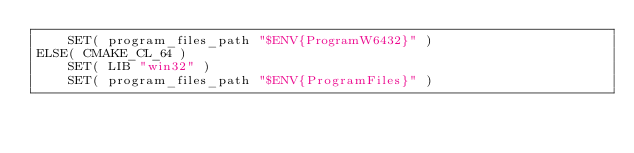Convert code to text. <code><loc_0><loc_0><loc_500><loc_500><_CMake_>    SET( program_files_path "$ENV{ProgramW6432}" )
ELSE( CMAKE_CL_64 )
    SET( LIB "win32" )
    SET( program_files_path "$ENV{ProgramFiles}" )</code> 